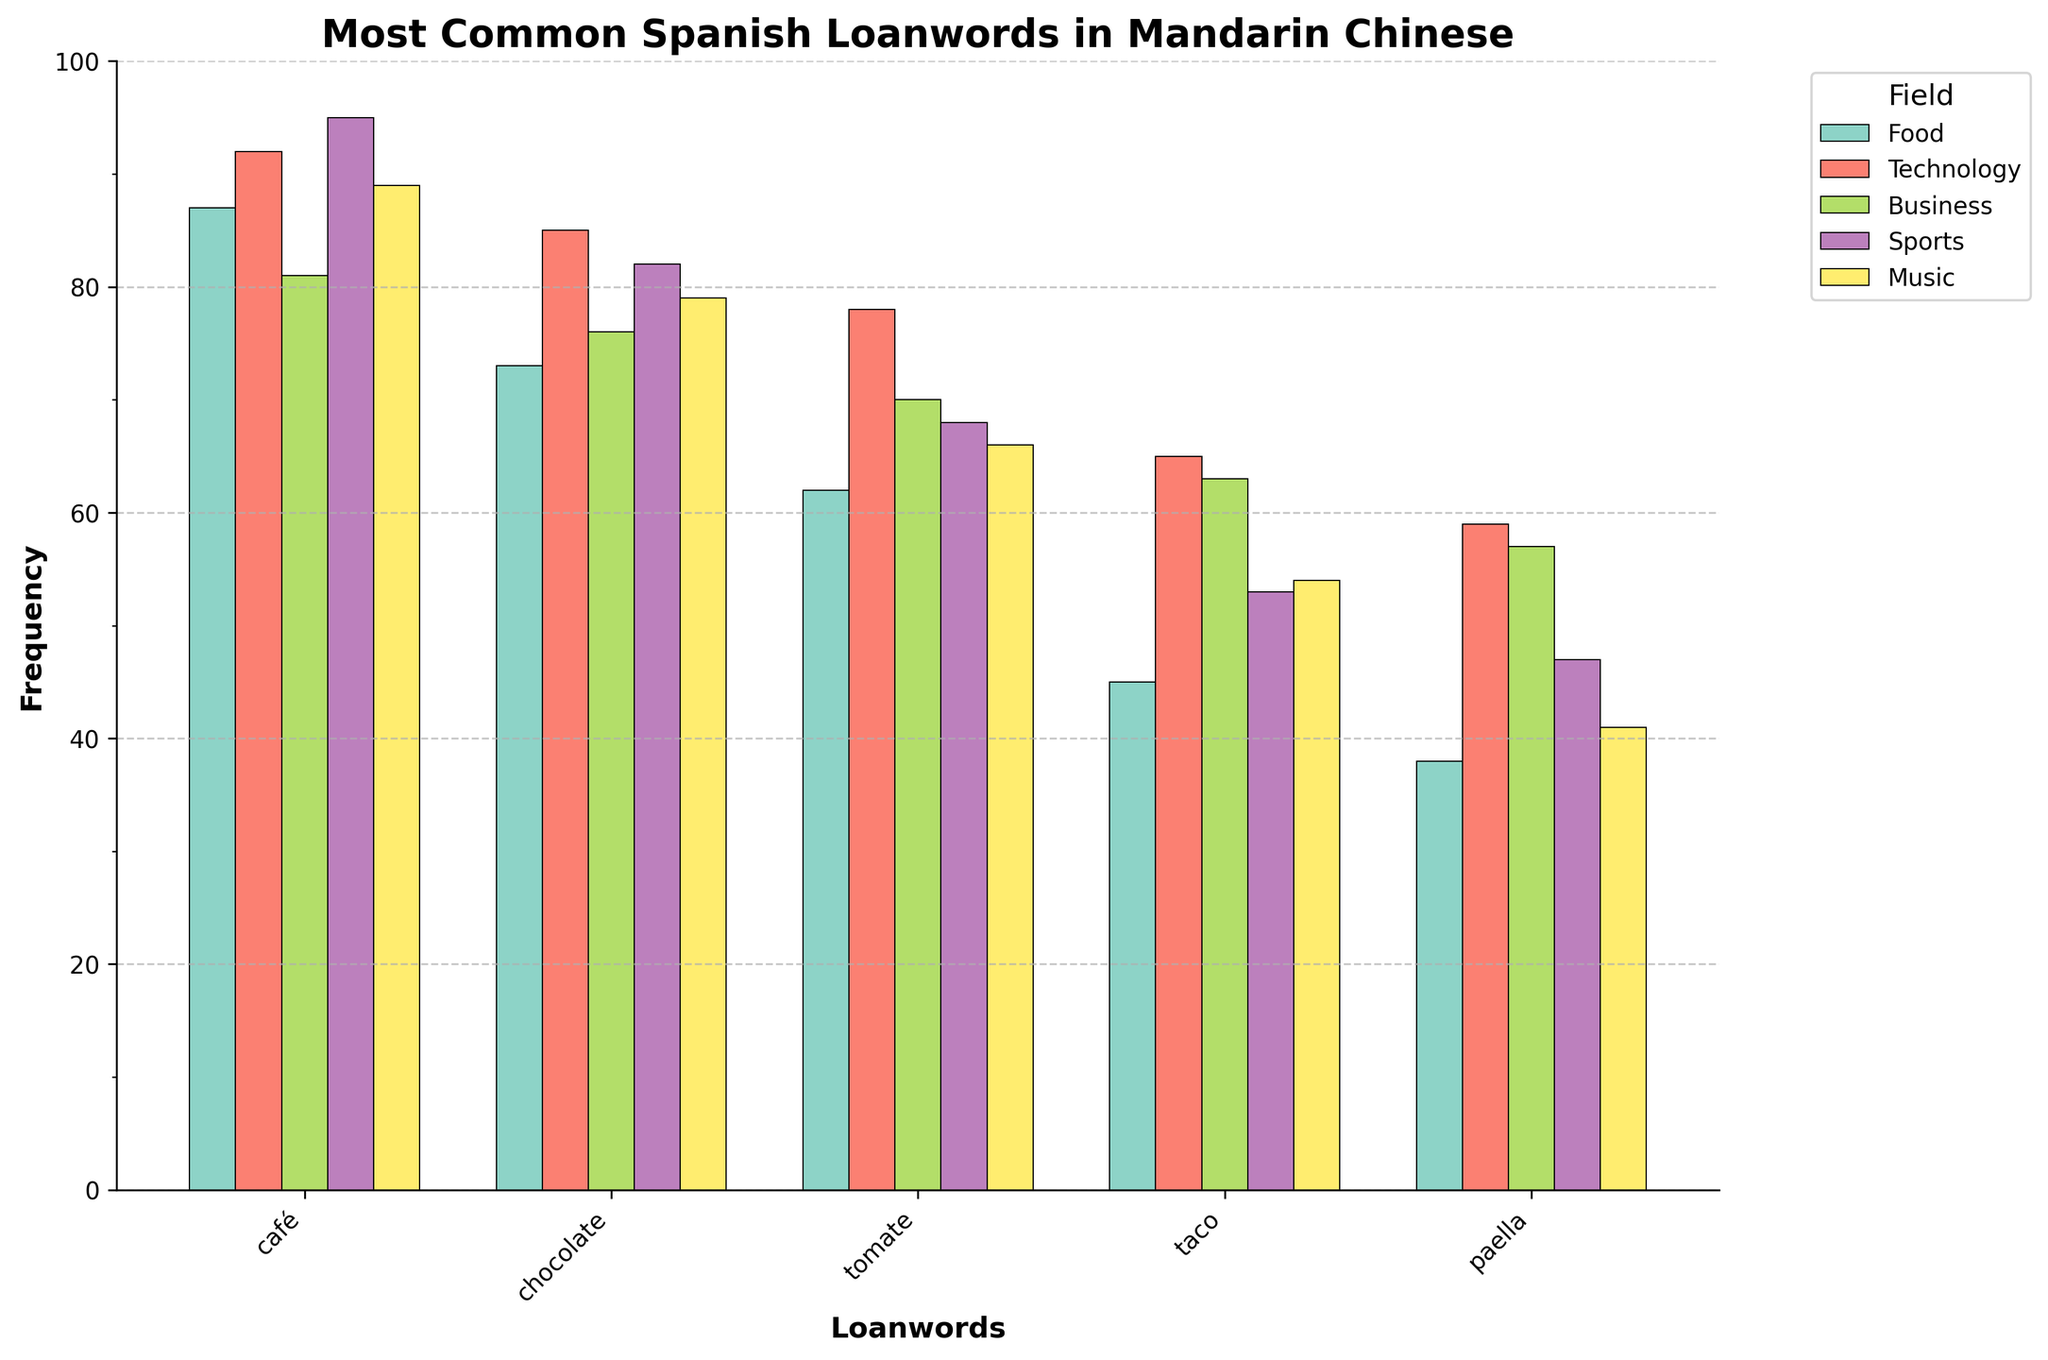Which field has the highest frequency loanword? Look at the bar with the highest value, which is in the "Sports" field ("fútbol" with a frequency of 95).
Answer: Sports Which food-related loanword has the highest frequency? Among the "Food" category, the highest bar corresponds to "café" with a frequency of 87.
Answer: café What is the difference in frequency between the most and least common technology loanwords? Identify the highest and lowest frequencies in the "Technology" field ("ordenador" with 92 and "televisión" with 59), then compute the difference: 92 - 59 = 33.
Answer: 33 Which field has more common loanwords, Music or Business? Compare the highest frequencies in "Music" ("guitarra" with 89) and "Business" ("empresa" with 81). Music has a higher frequency.
Answer: Music What is the average frequency of the top three food-related loanwords? Look at the top three frequencies in the "Food" category ("café" with 87, "chocolate" with 73, and "tomate" with 62). Calculate the average: (87 + 73 + 62) / 3 = 222 / 3 = 74.
Answer: 74 How many loanwords have a frequency greater than 80? Count the bars with frequencies greater than 80: "ordenador" (92), "fútbol" (95), "café" (87), "móvil" (85), "baloncesto" (82), "empresa" (81), and "guitarra" (89). There are 7 such loanwords.
Answer: 7 Which loanword in "Business" has the lowest frequency? Identify the loanword with the smallest bar in the "Business" category, which is "salario" with a frequency of 57.
Answer: salario What is the total frequency of all "Sports" loanwords? Sum all the frequencies in the "Sports" category ("fútbol" 95, "baloncesto" 82, "tenis" 68, "golf" 53, "béisbol" 47): 95 + 82 + 68 + 53 + 47 = 345.
Answer: 345 How does the frequency of "internet" compare with "oficina"? "Internet" has a frequency of 78 and "oficina" has a frequency of 70. "Internet" is more frequent than "oficina".
Answer: "Internet" is more frequent How many loanwords in the Music field have frequencies above 60? Count the bars with frequencies greater than 60 in "Music": "guitarra" (89), "piano" (79), and "salsa" (66). There are 3 such loanwords.
Answer: 3 